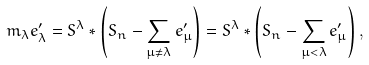Convert formula to latex. <formula><loc_0><loc_0><loc_500><loc_500>m _ { \lambda } e ^ { \prime } _ { \lambda } = S ^ { \lambda } * \left ( S _ { n } - \sum _ { \mu \neq \lambda } e ^ { \prime } _ { \mu } \right ) = S ^ { \lambda } * \left ( S _ { n } - \sum _ { \mu < \lambda } e ^ { \prime } _ { \mu } \right ) ,</formula> 